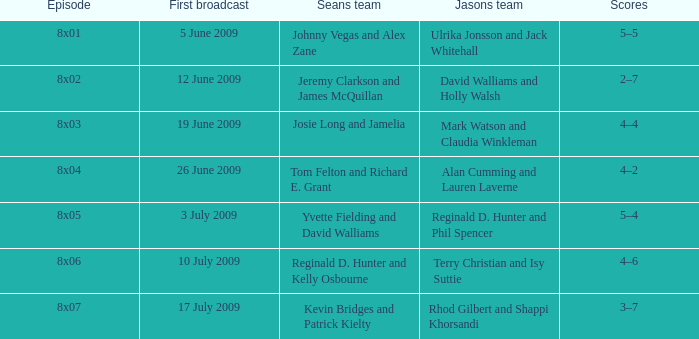Who constituted jason's team in the 12 june 2009 episode? David Walliams and Holly Walsh. 